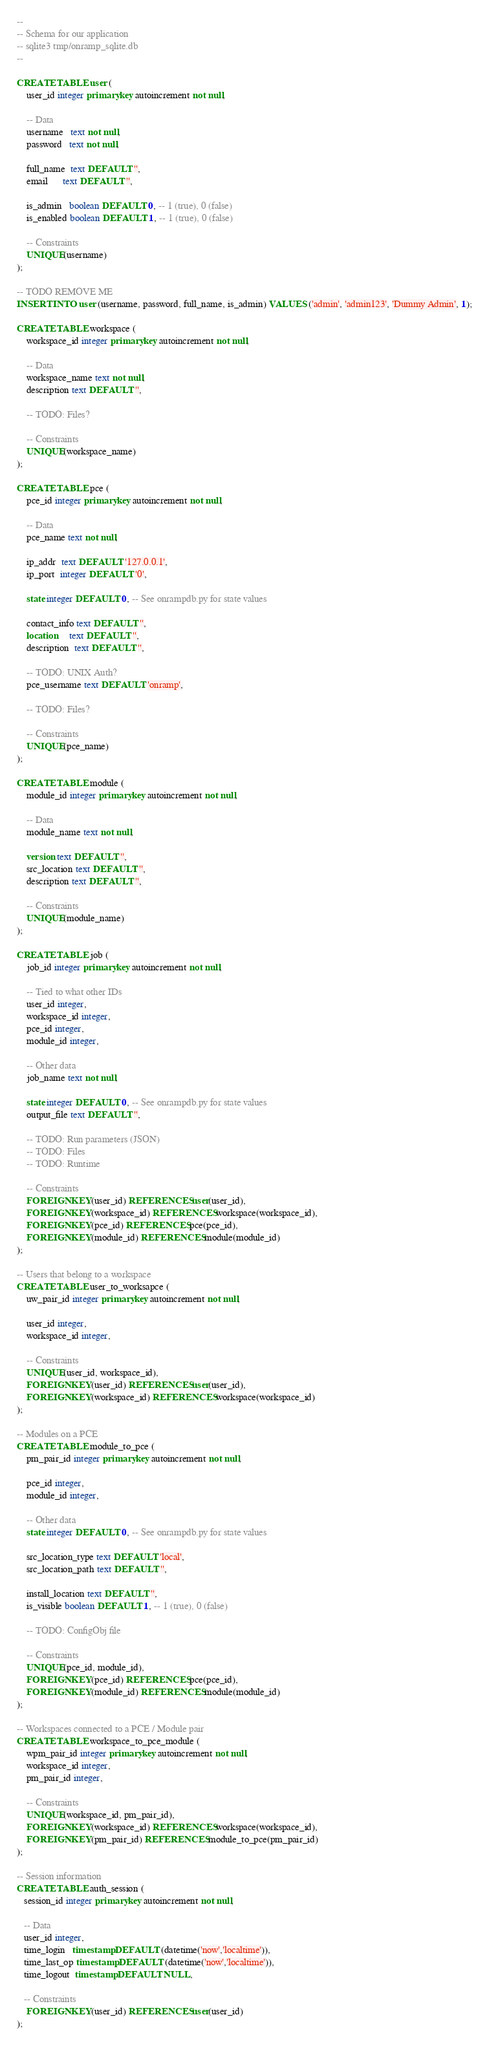<code> <loc_0><loc_0><loc_500><loc_500><_SQL_>--
-- Schema for our application
-- sqlite3 tmp/onramp_sqlite.db 
--

CREATE TABLE user (
    user_id integer primary key autoincrement not null,

    -- Data
    username   text not null,
    password   text not null,

    full_name  text DEFAULT '',
    email      text DEFAULT '',
    
    is_admin   boolean DEFAULT 0, -- 1 (true), 0 (false)
    is_enabled boolean DEFAULT 1, -- 1 (true), 0 (false)

    -- Constraints
    UNIQUE(username)
);

-- TODO REMOVE ME
INSERT INTO user (username, password, full_name, is_admin) VALUES ('admin', 'admin123', 'Dummy Admin', 1);

CREATE TABLE workspace (
    workspace_id integer primary key autoincrement not null,

    -- Data
    workspace_name text not null,
    description text DEFAULT '',

    -- TODO: Files?

    -- Constraints
    UNIQUE(workspace_name)
);

CREATE TABLE pce (
    pce_id integer primary key autoincrement not null,

    -- Data
    pce_name text not null,

    ip_addr  text DEFAULT '127.0.0.1',
    ip_port  integer DEFAULT '0',

    state integer DEFAULT 0, -- See onrampdb.py for state values

    contact_info text DEFAULT '',
    location     text DEFAULT '',
    description  text DEFAULT '',

    -- TODO: UNIX Auth?
    pce_username text DEFAULT 'onramp',

    -- TODO: Files?

    -- Constraints
    UNIQUE(pce_name)
);

CREATE TABLE module (
    module_id integer primary key autoincrement not null,

    -- Data
    module_name text not null,

    version text DEFAULT '',
    src_location text DEFAULT '',
    description text DEFAULT '',

    -- Constraints
    UNIQUE(module_name)
);

CREATE TABLE job (
    job_id integer primary key autoincrement not null,

    -- Tied to what other IDs
    user_id integer,
    workspace_id integer,
    pce_id integer,
    module_id integer,

    -- Other data
    job_name text not null,

    state integer DEFAULT 0, -- See onrampdb.py for state values
    output_file text DEFAULT '',

    -- TODO: Run parameters (JSON)
    -- TODO: Files
    -- TODO: Runtime

    -- Constraints
    FOREIGN KEY(user_id) REFERENCES user(user_id),
    FOREIGN KEY(workspace_id) REFERENCES workspace(workspace_id),
    FOREIGN KEY(pce_id) REFERENCES pce(pce_id),
    FOREIGN KEY(module_id) REFERENCES module(module_id)
);

-- Users that belong to a workspace
CREATE TABLE user_to_worksapce (
    uw_pair_id integer primary key autoincrement not null,

    user_id integer,
    workspace_id integer,

    -- Constraints
    UNIQUE(user_id, workspace_id),
    FOREIGN KEY(user_id) REFERENCES user(user_id),
    FOREIGN KEY(workspace_id) REFERENCES workspace(workspace_id)
);

-- Modules on a PCE
CREATE TABLE module_to_pce (
    pm_pair_id integer primary key autoincrement not null,

    pce_id integer,
    module_id integer,

    -- Other data
    state integer DEFAULT 0, -- See onrampdb.py for state values

    src_location_type text DEFAULT 'local',
    src_location_path text DEFAULT '',

    install_location text DEFAULT '',
    is_visible boolean DEFAULT 1, -- 1 (true), 0 (false)

    -- TODO: ConfigObj file

    -- Constraints
    UNIQUE(pce_id, module_id),
    FOREIGN KEY(pce_id) REFERENCES pce(pce_id),
    FOREIGN KEY(module_id) REFERENCES module(module_id)
);

-- Workspaces connected to a PCE / Module pair
CREATE TABLE workspace_to_pce_module (
    wpm_pair_id integer primary key autoincrement not null,
    workspace_id integer,
    pm_pair_id integer,

    -- Constraints
    UNIQUE(workspace_id, pm_pair_id),
    FOREIGN KEY(workspace_id) REFERENCES workspace(workspace_id),
    FOREIGN KEY(pm_pair_id) REFERENCES module_to_pce(pm_pair_id)
);

-- Session information
CREATE TABLE auth_session (
   session_id integer primary key autoincrement not null,

   -- Data
   user_id integer,
   time_login   timestamp DEFAULT (datetime('now','localtime')),
   time_last_op timestamp DEFAULT (datetime('now','localtime')),
   time_logout  timestamp DEFAULT NULL,

   -- Constraints
    FOREIGN KEY(user_id) REFERENCES user(user_id)
);
</code> 